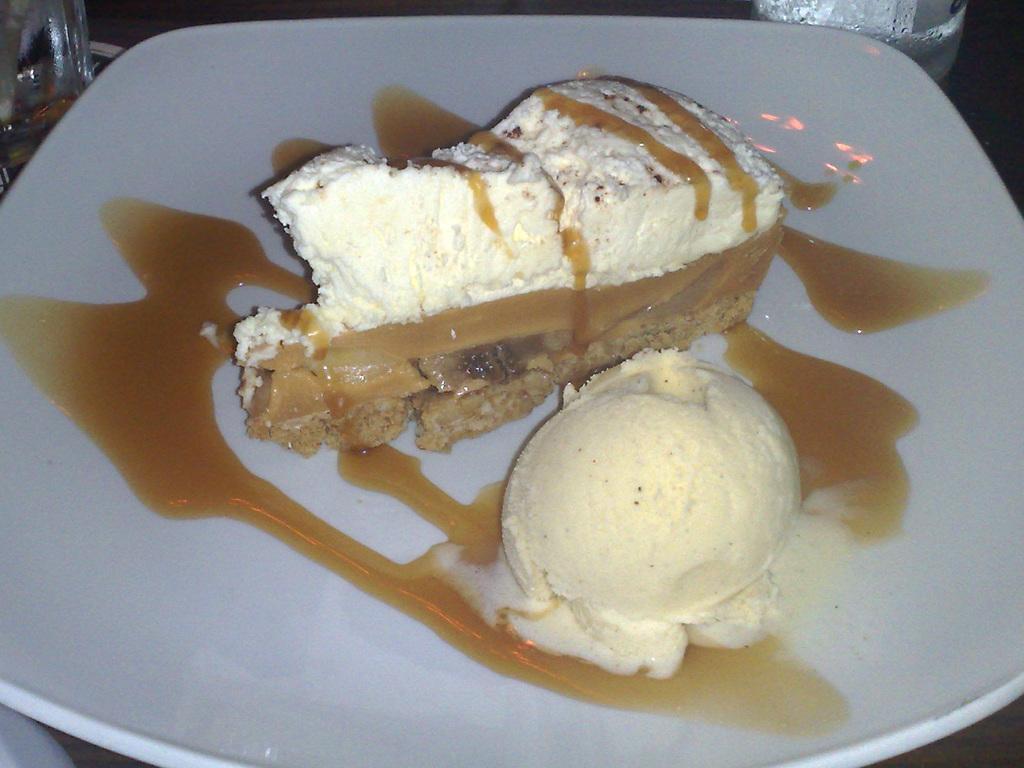Can you describe this image briefly? In the front of the image we can see food in white plate. At the top of the image there are glasses.   